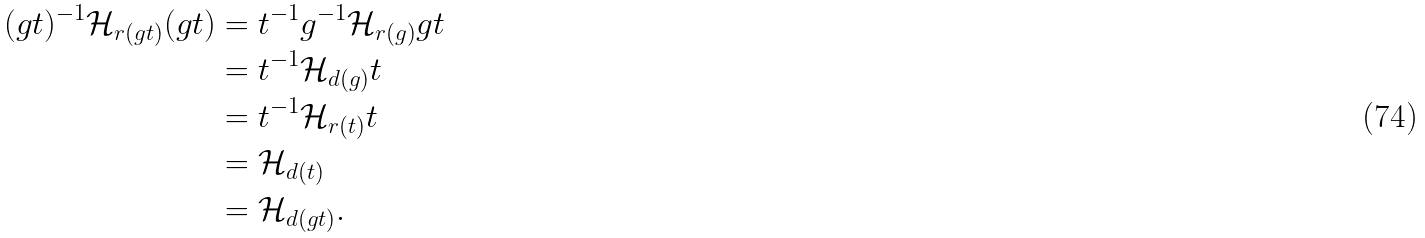<formula> <loc_0><loc_0><loc_500><loc_500>( g t ) ^ { - 1 } \mathcal { H } _ { r ( g t ) } ( g t ) & = t ^ { - 1 } g ^ { - 1 } \mathcal { H } _ { r ( g ) } g t \\ & = t ^ { - 1 } \mathcal { H } _ { d ( g ) } t \\ & = t ^ { - 1 } \mathcal { H } _ { r ( t ) } t \\ & = \mathcal { H } _ { d ( t ) } \\ & = \mathcal { H } _ { d ( g t ) } .</formula> 